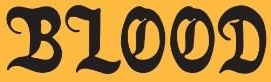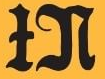Read the text content from these images in order, separated by a semicolon. BLOOD; IN 